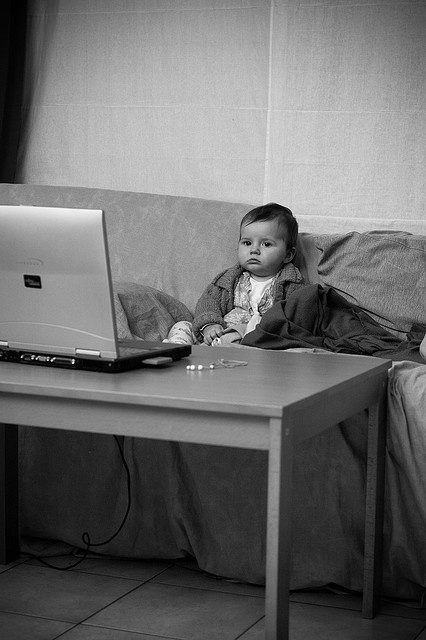Describe the objects in this image and their specific colors. I can see couch in black, darkgray, gray, and lightgray tones, laptop in black, darkgray, gray, and lightgray tones, and people in black, gray, darkgray, and lightgray tones in this image. 